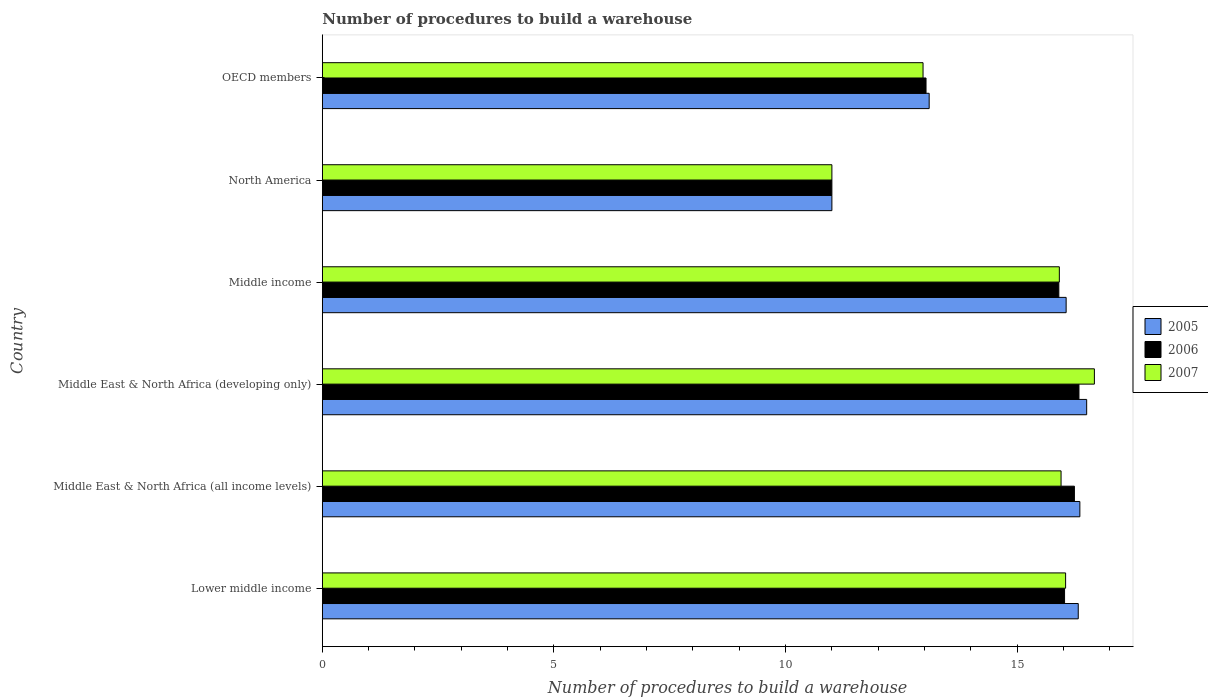Are the number of bars per tick equal to the number of legend labels?
Your answer should be very brief. Yes. Are the number of bars on each tick of the Y-axis equal?
Your answer should be very brief. Yes. How many bars are there on the 3rd tick from the bottom?
Your answer should be compact. 3. What is the number of procedures to build a warehouse in in 2006 in Middle East & North Africa (all income levels)?
Your answer should be compact. 16.24. Across all countries, what is the maximum number of procedures to build a warehouse in in 2005?
Offer a terse response. 16.5. Across all countries, what is the minimum number of procedures to build a warehouse in in 2007?
Your answer should be very brief. 11. In which country was the number of procedures to build a warehouse in in 2006 maximum?
Your answer should be compact. Middle East & North Africa (developing only). In which country was the number of procedures to build a warehouse in in 2006 minimum?
Provide a succinct answer. North America. What is the total number of procedures to build a warehouse in in 2007 in the graph?
Your answer should be very brief. 88.54. What is the difference between the number of procedures to build a warehouse in in 2006 in Lower middle income and that in OECD members?
Your answer should be very brief. 2.99. What is the difference between the number of procedures to build a warehouse in in 2006 in Middle East & North Africa (developing only) and the number of procedures to build a warehouse in in 2007 in Middle East & North Africa (all income levels)?
Provide a succinct answer. 0.39. What is the average number of procedures to build a warehouse in in 2005 per country?
Your answer should be compact. 14.89. What is the difference between the number of procedures to build a warehouse in in 2007 and number of procedures to build a warehouse in in 2005 in Middle East & North Africa (developing only)?
Your answer should be compact. 0.17. What is the ratio of the number of procedures to build a warehouse in in 2005 in Lower middle income to that in Middle East & North Africa (all income levels)?
Your answer should be very brief. 1. Is the difference between the number of procedures to build a warehouse in in 2007 in North America and OECD members greater than the difference between the number of procedures to build a warehouse in in 2005 in North America and OECD members?
Your answer should be very brief. Yes. What is the difference between the highest and the second highest number of procedures to build a warehouse in in 2006?
Your answer should be very brief. 0.1. What is the difference between the highest and the lowest number of procedures to build a warehouse in in 2006?
Give a very brief answer. 5.33. What does the 2nd bar from the bottom in Middle income represents?
Keep it short and to the point. 2006. Is it the case that in every country, the sum of the number of procedures to build a warehouse in in 2007 and number of procedures to build a warehouse in in 2005 is greater than the number of procedures to build a warehouse in in 2006?
Keep it short and to the point. Yes. How many bars are there?
Offer a very short reply. 18. How many countries are there in the graph?
Provide a short and direct response. 6. What is the difference between two consecutive major ticks on the X-axis?
Offer a very short reply. 5. Does the graph contain grids?
Offer a very short reply. No. Where does the legend appear in the graph?
Your answer should be compact. Center right. How many legend labels are there?
Keep it short and to the point. 3. What is the title of the graph?
Keep it short and to the point. Number of procedures to build a warehouse. What is the label or title of the X-axis?
Make the answer very short. Number of procedures to build a warehouse. What is the label or title of the Y-axis?
Ensure brevity in your answer.  Country. What is the Number of procedures to build a warehouse in 2005 in Lower middle income?
Offer a terse response. 16.32. What is the Number of procedures to build a warehouse in 2006 in Lower middle income?
Provide a succinct answer. 16.02. What is the Number of procedures to build a warehouse in 2007 in Lower middle income?
Offer a terse response. 16.05. What is the Number of procedures to build a warehouse of 2005 in Middle East & North Africa (all income levels)?
Offer a very short reply. 16.35. What is the Number of procedures to build a warehouse in 2006 in Middle East & North Africa (all income levels)?
Your response must be concise. 16.24. What is the Number of procedures to build a warehouse in 2007 in Middle East & North Africa (all income levels)?
Make the answer very short. 15.95. What is the Number of procedures to build a warehouse in 2005 in Middle East & North Africa (developing only)?
Offer a very short reply. 16.5. What is the Number of procedures to build a warehouse in 2006 in Middle East & North Africa (developing only)?
Your answer should be very brief. 16.33. What is the Number of procedures to build a warehouse of 2007 in Middle East & North Africa (developing only)?
Give a very brief answer. 16.67. What is the Number of procedures to build a warehouse in 2005 in Middle income?
Your answer should be compact. 16.06. What is the Number of procedures to build a warehouse in 2006 in Middle income?
Offer a very short reply. 15.9. What is the Number of procedures to build a warehouse of 2007 in Middle income?
Keep it short and to the point. 15.91. What is the Number of procedures to build a warehouse in 2007 in North America?
Your answer should be compact. 11. What is the Number of procedures to build a warehouse of 2006 in OECD members?
Your response must be concise. 13.03. What is the Number of procedures to build a warehouse of 2007 in OECD members?
Ensure brevity in your answer.  12.97. Across all countries, what is the maximum Number of procedures to build a warehouse of 2005?
Provide a short and direct response. 16.5. Across all countries, what is the maximum Number of procedures to build a warehouse of 2006?
Keep it short and to the point. 16.33. Across all countries, what is the maximum Number of procedures to build a warehouse of 2007?
Offer a terse response. 16.67. What is the total Number of procedures to build a warehouse in 2005 in the graph?
Ensure brevity in your answer.  89.33. What is the total Number of procedures to build a warehouse of 2006 in the graph?
Give a very brief answer. 88.52. What is the total Number of procedures to build a warehouse in 2007 in the graph?
Offer a terse response. 88.54. What is the difference between the Number of procedures to build a warehouse in 2005 in Lower middle income and that in Middle East & North Africa (all income levels)?
Ensure brevity in your answer.  -0.03. What is the difference between the Number of procedures to build a warehouse in 2006 in Lower middle income and that in Middle East & North Africa (all income levels)?
Your answer should be very brief. -0.21. What is the difference between the Number of procedures to build a warehouse in 2007 in Lower middle income and that in Middle East & North Africa (all income levels)?
Ensure brevity in your answer.  0.1. What is the difference between the Number of procedures to build a warehouse in 2005 in Lower middle income and that in Middle East & North Africa (developing only)?
Provide a succinct answer. -0.18. What is the difference between the Number of procedures to build a warehouse in 2006 in Lower middle income and that in Middle East & North Africa (developing only)?
Give a very brief answer. -0.31. What is the difference between the Number of procedures to build a warehouse of 2007 in Lower middle income and that in Middle East & North Africa (developing only)?
Offer a very short reply. -0.62. What is the difference between the Number of procedures to build a warehouse of 2005 in Lower middle income and that in Middle income?
Provide a short and direct response. 0.26. What is the difference between the Number of procedures to build a warehouse in 2006 in Lower middle income and that in Middle income?
Ensure brevity in your answer.  0.12. What is the difference between the Number of procedures to build a warehouse of 2007 in Lower middle income and that in Middle income?
Provide a succinct answer. 0.14. What is the difference between the Number of procedures to build a warehouse in 2005 in Lower middle income and that in North America?
Your answer should be very brief. 5.32. What is the difference between the Number of procedures to build a warehouse of 2006 in Lower middle income and that in North America?
Make the answer very short. 5.02. What is the difference between the Number of procedures to build a warehouse of 2007 in Lower middle income and that in North America?
Provide a succinct answer. 5.05. What is the difference between the Number of procedures to build a warehouse in 2005 in Lower middle income and that in OECD members?
Provide a succinct answer. 3.22. What is the difference between the Number of procedures to build a warehouse in 2006 in Lower middle income and that in OECD members?
Provide a succinct answer. 2.99. What is the difference between the Number of procedures to build a warehouse of 2007 in Lower middle income and that in OECD members?
Provide a short and direct response. 3.08. What is the difference between the Number of procedures to build a warehouse of 2005 in Middle East & North Africa (all income levels) and that in Middle East & North Africa (developing only)?
Keep it short and to the point. -0.15. What is the difference between the Number of procedures to build a warehouse of 2006 in Middle East & North Africa (all income levels) and that in Middle East & North Africa (developing only)?
Your answer should be very brief. -0.1. What is the difference between the Number of procedures to build a warehouse in 2007 in Middle East & North Africa (all income levels) and that in Middle East & North Africa (developing only)?
Provide a succinct answer. -0.72. What is the difference between the Number of procedures to build a warehouse in 2005 in Middle East & North Africa (all income levels) and that in Middle income?
Keep it short and to the point. 0.3. What is the difference between the Number of procedures to build a warehouse in 2006 in Middle East & North Africa (all income levels) and that in Middle income?
Offer a terse response. 0.34. What is the difference between the Number of procedures to build a warehouse of 2007 in Middle East & North Africa (all income levels) and that in Middle income?
Offer a very short reply. 0.04. What is the difference between the Number of procedures to build a warehouse of 2005 in Middle East & North Africa (all income levels) and that in North America?
Provide a succinct answer. 5.35. What is the difference between the Number of procedures to build a warehouse of 2006 in Middle East & North Africa (all income levels) and that in North America?
Offer a very short reply. 5.24. What is the difference between the Number of procedures to build a warehouse in 2007 in Middle East & North Africa (all income levels) and that in North America?
Your answer should be very brief. 4.95. What is the difference between the Number of procedures to build a warehouse of 2005 in Middle East & North Africa (all income levels) and that in OECD members?
Make the answer very short. 3.25. What is the difference between the Number of procedures to build a warehouse in 2006 in Middle East & North Africa (all income levels) and that in OECD members?
Give a very brief answer. 3.2. What is the difference between the Number of procedures to build a warehouse of 2007 in Middle East & North Africa (all income levels) and that in OECD members?
Offer a terse response. 2.98. What is the difference between the Number of procedures to build a warehouse in 2005 in Middle East & North Africa (developing only) and that in Middle income?
Keep it short and to the point. 0.44. What is the difference between the Number of procedures to build a warehouse of 2006 in Middle East & North Africa (developing only) and that in Middle income?
Ensure brevity in your answer.  0.43. What is the difference between the Number of procedures to build a warehouse in 2007 in Middle East & North Africa (developing only) and that in Middle income?
Your answer should be compact. 0.76. What is the difference between the Number of procedures to build a warehouse in 2006 in Middle East & North Africa (developing only) and that in North America?
Give a very brief answer. 5.33. What is the difference between the Number of procedures to build a warehouse of 2007 in Middle East & North Africa (developing only) and that in North America?
Offer a terse response. 5.67. What is the difference between the Number of procedures to build a warehouse in 2005 in Middle East & North Africa (developing only) and that in OECD members?
Your answer should be very brief. 3.4. What is the difference between the Number of procedures to build a warehouse of 2006 in Middle East & North Africa (developing only) and that in OECD members?
Provide a succinct answer. 3.3. What is the difference between the Number of procedures to build a warehouse in 2007 in Middle East & North Africa (developing only) and that in OECD members?
Give a very brief answer. 3.7. What is the difference between the Number of procedures to build a warehouse of 2005 in Middle income and that in North America?
Your answer should be compact. 5.06. What is the difference between the Number of procedures to build a warehouse of 2006 in Middle income and that in North America?
Your response must be concise. 4.9. What is the difference between the Number of procedures to build a warehouse of 2007 in Middle income and that in North America?
Offer a terse response. 4.91. What is the difference between the Number of procedures to build a warehouse in 2005 in Middle income and that in OECD members?
Your answer should be very brief. 2.96. What is the difference between the Number of procedures to build a warehouse of 2006 in Middle income and that in OECD members?
Ensure brevity in your answer.  2.87. What is the difference between the Number of procedures to build a warehouse in 2007 in Middle income and that in OECD members?
Give a very brief answer. 2.94. What is the difference between the Number of procedures to build a warehouse in 2006 in North America and that in OECD members?
Keep it short and to the point. -2.03. What is the difference between the Number of procedures to build a warehouse in 2007 in North America and that in OECD members?
Your answer should be very brief. -1.97. What is the difference between the Number of procedures to build a warehouse of 2005 in Lower middle income and the Number of procedures to build a warehouse of 2006 in Middle East & North Africa (all income levels)?
Keep it short and to the point. 0.08. What is the difference between the Number of procedures to build a warehouse in 2005 in Lower middle income and the Number of procedures to build a warehouse in 2007 in Middle East & North Africa (all income levels)?
Ensure brevity in your answer.  0.37. What is the difference between the Number of procedures to build a warehouse in 2006 in Lower middle income and the Number of procedures to build a warehouse in 2007 in Middle East & North Africa (all income levels)?
Provide a short and direct response. 0.08. What is the difference between the Number of procedures to build a warehouse of 2005 in Lower middle income and the Number of procedures to build a warehouse of 2006 in Middle East & North Africa (developing only)?
Your response must be concise. -0.02. What is the difference between the Number of procedures to build a warehouse in 2005 in Lower middle income and the Number of procedures to build a warehouse in 2007 in Middle East & North Africa (developing only)?
Ensure brevity in your answer.  -0.35. What is the difference between the Number of procedures to build a warehouse of 2006 in Lower middle income and the Number of procedures to build a warehouse of 2007 in Middle East & North Africa (developing only)?
Your answer should be compact. -0.64. What is the difference between the Number of procedures to build a warehouse of 2005 in Lower middle income and the Number of procedures to build a warehouse of 2006 in Middle income?
Make the answer very short. 0.42. What is the difference between the Number of procedures to build a warehouse of 2005 in Lower middle income and the Number of procedures to build a warehouse of 2007 in Middle income?
Provide a succinct answer. 0.41. What is the difference between the Number of procedures to build a warehouse in 2006 in Lower middle income and the Number of procedures to build a warehouse in 2007 in Middle income?
Give a very brief answer. 0.11. What is the difference between the Number of procedures to build a warehouse of 2005 in Lower middle income and the Number of procedures to build a warehouse of 2006 in North America?
Your answer should be compact. 5.32. What is the difference between the Number of procedures to build a warehouse of 2005 in Lower middle income and the Number of procedures to build a warehouse of 2007 in North America?
Keep it short and to the point. 5.32. What is the difference between the Number of procedures to build a warehouse of 2006 in Lower middle income and the Number of procedures to build a warehouse of 2007 in North America?
Provide a short and direct response. 5.02. What is the difference between the Number of procedures to build a warehouse in 2005 in Lower middle income and the Number of procedures to build a warehouse in 2006 in OECD members?
Keep it short and to the point. 3.29. What is the difference between the Number of procedures to build a warehouse of 2005 in Lower middle income and the Number of procedures to build a warehouse of 2007 in OECD members?
Offer a terse response. 3.35. What is the difference between the Number of procedures to build a warehouse in 2006 in Lower middle income and the Number of procedures to build a warehouse in 2007 in OECD members?
Keep it short and to the point. 3.06. What is the difference between the Number of procedures to build a warehouse of 2005 in Middle East & North Africa (all income levels) and the Number of procedures to build a warehouse of 2006 in Middle East & North Africa (developing only)?
Make the answer very short. 0.02. What is the difference between the Number of procedures to build a warehouse in 2005 in Middle East & North Africa (all income levels) and the Number of procedures to build a warehouse in 2007 in Middle East & North Africa (developing only)?
Offer a very short reply. -0.31. What is the difference between the Number of procedures to build a warehouse in 2006 in Middle East & North Africa (all income levels) and the Number of procedures to build a warehouse in 2007 in Middle East & North Africa (developing only)?
Make the answer very short. -0.43. What is the difference between the Number of procedures to build a warehouse in 2005 in Middle East & North Africa (all income levels) and the Number of procedures to build a warehouse in 2006 in Middle income?
Give a very brief answer. 0.45. What is the difference between the Number of procedures to build a warehouse of 2005 in Middle East & North Africa (all income levels) and the Number of procedures to build a warehouse of 2007 in Middle income?
Your answer should be compact. 0.44. What is the difference between the Number of procedures to build a warehouse of 2006 in Middle East & North Africa (all income levels) and the Number of procedures to build a warehouse of 2007 in Middle income?
Ensure brevity in your answer.  0.33. What is the difference between the Number of procedures to build a warehouse of 2005 in Middle East & North Africa (all income levels) and the Number of procedures to build a warehouse of 2006 in North America?
Give a very brief answer. 5.35. What is the difference between the Number of procedures to build a warehouse in 2005 in Middle East & North Africa (all income levels) and the Number of procedures to build a warehouse in 2007 in North America?
Offer a terse response. 5.35. What is the difference between the Number of procedures to build a warehouse of 2006 in Middle East & North Africa (all income levels) and the Number of procedures to build a warehouse of 2007 in North America?
Offer a terse response. 5.24. What is the difference between the Number of procedures to build a warehouse in 2005 in Middle East & North Africa (all income levels) and the Number of procedures to build a warehouse in 2006 in OECD members?
Your answer should be very brief. 3.32. What is the difference between the Number of procedures to build a warehouse of 2005 in Middle East & North Africa (all income levels) and the Number of procedures to build a warehouse of 2007 in OECD members?
Provide a short and direct response. 3.39. What is the difference between the Number of procedures to build a warehouse in 2006 in Middle East & North Africa (all income levels) and the Number of procedures to build a warehouse in 2007 in OECD members?
Your answer should be compact. 3.27. What is the difference between the Number of procedures to build a warehouse in 2005 in Middle East & North Africa (developing only) and the Number of procedures to build a warehouse in 2006 in Middle income?
Your response must be concise. 0.6. What is the difference between the Number of procedures to build a warehouse of 2005 in Middle East & North Africa (developing only) and the Number of procedures to build a warehouse of 2007 in Middle income?
Your response must be concise. 0.59. What is the difference between the Number of procedures to build a warehouse in 2006 in Middle East & North Africa (developing only) and the Number of procedures to build a warehouse in 2007 in Middle income?
Your response must be concise. 0.42. What is the difference between the Number of procedures to build a warehouse in 2005 in Middle East & North Africa (developing only) and the Number of procedures to build a warehouse in 2007 in North America?
Offer a terse response. 5.5. What is the difference between the Number of procedures to build a warehouse of 2006 in Middle East & North Africa (developing only) and the Number of procedures to build a warehouse of 2007 in North America?
Provide a succinct answer. 5.33. What is the difference between the Number of procedures to build a warehouse in 2005 in Middle East & North Africa (developing only) and the Number of procedures to build a warehouse in 2006 in OECD members?
Offer a very short reply. 3.47. What is the difference between the Number of procedures to build a warehouse of 2005 in Middle East & North Africa (developing only) and the Number of procedures to build a warehouse of 2007 in OECD members?
Provide a succinct answer. 3.53. What is the difference between the Number of procedures to build a warehouse in 2006 in Middle East & North Africa (developing only) and the Number of procedures to build a warehouse in 2007 in OECD members?
Keep it short and to the point. 3.37. What is the difference between the Number of procedures to build a warehouse in 2005 in Middle income and the Number of procedures to build a warehouse in 2006 in North America?
Your answer should be compact. 5.06. What is the difference between the Number of procedures to build a warehouse in 2005 in Middle income and the Number of procedures to build a warehouse in 2007 in North America?
Give a very brief answer. 5.06. What is the difference between the Number of procedures to build a warehouse of 2006 in Middle income and the Number of procedures to build a warehouse of 2007 in North America?
Provide a short and direct response. 4.9. What is the difference between the Number of procedures to build a warehouse in 2005 in Middle income and the Number of procedures to build a warehouse in 2006 in OECD members?
Give a very brief answer. 3.02. What is the difference between the Number of procedures to build a warehouse in 2005 in Middle income and the Number of procedures to build a warehouse in 2007 in OECD members?
Provide a succinct answer. 3.09. What is the difference between the Number of procedures to build a warehouse of 2006 in Middle income and the Number of procedures to build a warehouse of 2007 in OECD members?
Offer a very short reply. 2.93. What is the difference between the Number of procedures to build a warehouse in 2005 in North America and the Number of procedures to build a warehouse in 2006 in OECD members?
Provide a succinct answer. -2.03. What is the difference between the Number of procedures to build a warehouse of 2005 in North America and the Number of procedures to build a warehouse of 2007 in OECD members?
Offer a terse response. -1.97. What is the difference between the Number of procedures to build a warehouse of 2006 in North America and the Number of procedures to build a warehouse of 2007 in OECD members?
Your response must be concise. -1.97. What is the average Number of procedures to build a warehouse of 2005 per country?
Give a very brief answer. 14.89. What is the average Number of procedures to build a warehouse of 2006 per country?
Your response must be concise. 14.75. What is the average Number of procedures to build a warehouse of 2007 per country?
Ensure brevity in your answer.  14.76. What is the difference between the Number of procedures to build a warehouse in 2005 and Number of procedures to build a warehouse in 2006 in Lower middle income?
Provide a short and direct response. 0.3. What is the difference between the Number of procedures to build a warehouse of 2005 and Number of procedures to build a warehouse of 2007 in Lower middle income?
Keep it short and to the point. 0.27. What is the difference between the Number of procedures to build a warehouse in 2006 and Number of procedures to build a warehouse in 2007 in Lower middle income?
Your answer should be compact. -0.02. What is the difference between the Number of procedures to build a warehouse in 2005 and Number of procedures to build a warehouse in 2006 in Middle East & North Africa (all income levels)?
Your answer should be compact. 0.12. What is the difference between the Number of procedures to build a warehouse of 2005 and Number of procedures to build a warehouse of 2007 in Middle East & North Africa (all income levels)?
Your answer should be very brief. 0.41. What is the difference between the Number of procedures to build a warehouse of 2006 and Number of procedures to build a warehouse of 2007 in Middle East & North Africa (all income levels)?
Keep it short and to the point. 0.29. What is the difference between the Number of procedures to build a warehouse of 2005 and Number of procedures to build a warehouse of 2007 in Middle East & North Africa (developing only)?
Your answer should be compact. -0.17. What is the difference between the Number of procedures to build a warehouse of 2005 and Number of procedures to build a warehouse of 2006 in Middle income?
Give a very brief answer. 0.16. What is the difference between the Number of procedures to build a warehouse in 2005 and Number of procedures to build a warehouse in 2007 in Middle income?
Your answer should be compact. 0.15. What is the difference between the Number of procedures to build a warehouse of 2006 and Number of procedures to build a warehouse of 2007 in Middle income?
Make the answer very short. -0.01. What is the difference between the Number of procedures to build a warehouse in 2005 and Number of procedures to build a warehouse in 2006 in North America?
Your answer should be compact. 0. What is the difference between the Number of procedures to build a warehouse in 2005 and Number of procedures to build a warehouse in 2007 in North America?
Provide a short and direct response. 0. What is the difference between the Number of procedures to build a warehouse in 2005 and Number of procedures to build a warehouse in 2006 in OECD members?
Your answer should be very brief. 0.07. What is the difference between the Number of procedures to build a warehouse of 2005 and Number of procedures to build a warehouse of 2007 in OECD members?
Make the answer very short. 0.13. What is the difference between the Number of procedures to build a warehouse of 2006 and Number of procedures to build a warehouse of 2007 in OECD members?
Your response must be concise. 0.06. What is the ratio of the Number of procedures to build a warehouse in 2006 in Lower middle income to that in Middle East & North Africa (all income levels)?
Provide a succinct answer. 0.99. What is the ratio of the Number of procedures to build a warehouse of 2007 in Lower middle income to that in Middle East & North Africa (all income levels)?
Ensure brevity in your answer.  1.01. What is the ratio of the Number of procedures to build a warehouse of 2005 in Lower middle income to that in Middle East & North Africa (developing only)?
Offer a very short reply. 0.99. What is the ratio of the Number of procedures to build a warehouse of 2007 in Lower middle income to that in Middle East & North Africa (developing only)?
Offer a terse response. 0.96. What is the ratio of the Number of procedures to build a warehouse in 2005 in Lower middle income to that in Middle income?
Make the answer very short. 1.02. What is the ratio of the Number of procedures to build a warehouse of 2006 in Lower middle income to that in Middle income?
Your answer should be very brief. 1.01. What is the ratio of the Number of procedures to build a warehouse of 2007 in Lower middle income to that in Middle income?
Give a very brief answer. 1.01. What is the ratio of the Number of procedures to build a warehouse in 2005 in Lower middle income to that in North America?
Provide a succinct answer. 1.48. What is the ratio of the Number of procedures to build a warehouse of 2006 in Lower middle income to that in North America?
Ensure brevity in your answer.  1.46. What is the ratio of the Number of procedures to build a warehouse in 2007 in Lower middle income to that in North America?
Make the answer very short. 1.46. What is the ratio of the Number of procedures to build a warehouse in 2005 in Lower middle income to that in OECD members?
Offer a very short reply. 1.25. What is the ratio of the Number of procedures to build a warehouse of 2006 in Lower middle income to that in OECD members?
Give a very brief answer. 1.23. What is the ratio of the Number of procedures to build a warehouse of 2007 in Lower middle income to that in OECD members?
Make the answer very short. 1.24. What is the ratio of the Number of procedures to build a warehouse of 2005 in Middle East & North Africa (all income levels) to that in Middle East & North Africa (developing only)?
Ensure brevity in your answer.  0.99. What is the ratio of the Number of procedures to build a warehouse of 2006 in Middle East & North Africa (all income levels) to that in Middle East & North Africa (developing only)?
Give a very brief answer. 0.99. What is the ratio of the Number of procedures to build a warehouse of 2007 in Middle East & North Africa (all income levels) to that in Middle East & North Africa (developing only)?
Offer a terse response. 0.96. What is the ratio of the Number of procedures to build a warehouse in 2005 in Middle East & North Africa (all income levels) to that in Middle income?
Ensure brevity in your answer.  1.02. What is the ratio of the Number of procedures to build a warehouse of 2006 in Middle East & North Africa (all income levels) to that in Middle income?
Offer a very short reply. 1.02. What is the ratio of the Number of procedures to build a warehouse in 2007 in Middle East & North Africa (all income levels) to that in Middle income?
Keep it short and to the point. 1. What is the ratio of the Number of procedures to build a warehouse of 2005 in Middle East & North Africa (all income levels) to that in North America?
Your answer should be very brief. 1.49. What is the ratio of the Number of procedures to build a warehouse of 2006 in Middle East & North Africa (all income levels) to that in North America?
Offer a very short reply. 1.48. What is the ratio of the Number of procedures to build a warehouse in 2007 in Middle East & North Africa (all income levels) to that in North America?
Your answer should be compact. 1.45. What is the ratio of the Number of procedures to build a warehouse of 2005 in Middle East & North Africa (all income levels) to that in OECD members?
Give a very brief answer. 1.25. What is the ratio of the Number of procedures to build a warehouse in 2006 in Middle East & North Africa (all income levels) to that in OECD members?
Provide a short and direct response. 1.25. What is the ratio of the Number of procedures to build a warehouse of 2007 in Middle East & North Africa (all income levels) to that in OECD members?
Your answer should be very brief. 1.23. What is the ratio of the Number of procedures to build a warehouse of 2005 in Middle East & North Africa (developing only) to that in Middle income?
Ensure brevity in your answer.  1.03. What is the ratio of the Number of procedures to build a warehouse in 2006 in Middle East & North Africa (developing only) to that in Middle income?
Make the answer very short. 1.03. What is the ratio of the Number of procedures to build a warehouse of 2007 in Middle East & North Africa (developing only) to that in Middle income?
Your response must be concise. 1.05. What is the ratio of the Number of procedures to build a warehouse in 2006 in Middle East & North Africa (developing only) to that in North America?
Your answer should be compact. 1.48. What is the ratio of the Number of procedures to build a warehouse in 2007 in Middle East & North Africa (developing only) to that in North America?
Provide a succinct answer. 1.52. What is the ratio of the Number of procedures to build a warehouse of 2005 in Middle East & North Africa (developing only) to that in OECD members?
Provide a succinct answer. 1.26. What is the ratio of the Number of procedures to build a warehouse of 2006 in Middle East & North Africa (developing only) to that in OECD members?
Your answer should be very brief. 1.25. What is the ratio of the Number of procedures to build a warehouse of 2007 in Middle East & North Africa (developing only) to that in OECD members?
Your answer should be very brief. 1.29. What is the ratio of the Number of procedures to build a warehouse in 2005 in Middle income to that in North America?
Your answer should be very brief. 1.46. What is the ratio of the Number of procedures to build a warehouse in 2006 in Middle income to that in North America?
Your answer should be compact. 1.45. What is the ratio of the Number of procedures to build a warehouse in 2007 in Middle income to that in North America?
Offer a terse response. 1.45. What is the ratio of the Number of procedures to build a warehouse of 2005 in Middle income to that in OECD members?
Provide a succinct answer. 1.23. What is the ratio of the Number of procedures to build a warehouse of 2006 in Middle income to that in OECD members?
Offer a terse response. 1.22. What is the ratio of the Number of procedures to build a warehouse in 2007 in Middle income to that in OECD members?
Give a very brief answer. 1.23. What is the ratio of the Number of procedures to build a warehouse of 2005 in North America to that in OECD members?
Your response must be concise. 0.84. What is the ratio of the Number of procedures to build a warehouse in 2006 in North America to that in OECD members?
Provide a succinct answer. 0.84. What is the ratio of the Number of procedures to build a warehouse of 2007 in North America to that in OECD members?
Give a very brief answer. 0.85. What is the difference between the highest and the second highest Number of procedures to build a warehouse in 2005?
Provide a short and direct response. 0.15. What is the difference between the highest and the second highest Number of procedures to build a warehouse in 2006?
Keep it short and to the point. 0.1. What is the difference between the highest and the second highest Number of procedures to build a warehouse in 2007?
Your response must be concise. 0.62. What is the difference between the highest and the lowest Number of procedures to build a warehouse of 2006?
Ensure brevity in your answer.  5.33. What is the difference between the highest and the lowest Number of procedures to build a warehouse in 2007?
Offer a terse response. 5.67. 